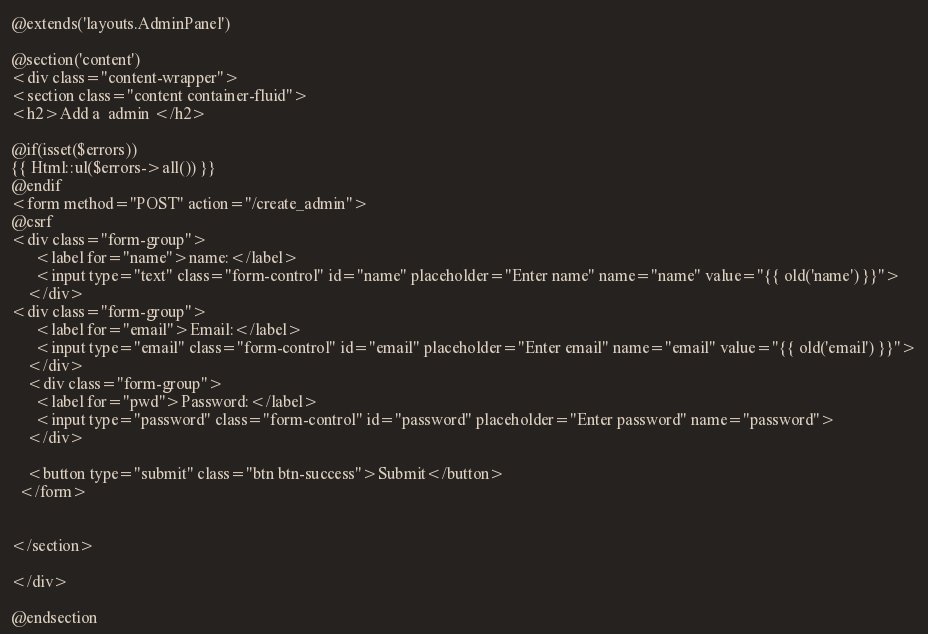<code> <loc_0><loc_0><loc_500><loc_500><_PHP_>@extends('layouts.AdminPanel')

@section('content')
<div class="content-wrapper">
<section class="content container-fluid">
<h2>Add a  admin </h2>

@if(isset($errors))
{{ Html::ul($errors->all()) }}
@endif
<form method="POST" action="/create_admin"> 
@csrf
<div class="form-group">
      <label for="name">name:</label>
      <input type="text" class="form-control" id="name" placeholder="Enter name" name="name" value="{{ old('name') }}">
    </div>
<div class="form-group">
      <label for="email">Email:</label>
      <input type="email" class="form-control" id="email" placeholder="Enter email" name="email" value="{{ old('email') }}">
    </div>
    <div class="form-group">
      <label for="pwd">Password:</label>
      <input type="password" class="form-control" id="password" placeholder="Enter password" name="password">
    </div>
    
    <button type="submit" class="btn btn-success">Submit</button>
  </form>


</section>

</div>

@endsection
</code> 